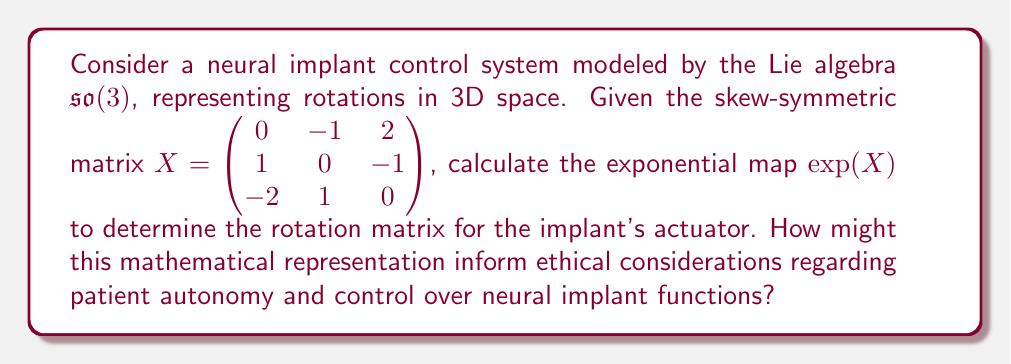What is the answer to this math problem? To calculate the exponential map for the given skew-symmetric matrix $X$, we'll follow these steps:

1) First, we need to find the eigenvalues of $X$. The characteristic polynomial is:
   $$\det(X - \lambda I) = -\lambda^3 - 6\lambda = -\lambda(\lambda^2 + 6) = 0$$
   The eigenvalues are $\lambda_1 = 0$, $\lambda_2 = i\sqrt{6}$, and $\lambda_3 = -i\sqrt{6}$.

2) The rotation angle $\theta$ can be calculated from the norm of $X$:
   $$\theta = \|X\| = \sqrt{(-1)^2 + 2^2 + 1^2 + (-1)^2 + (-2)^2 + 1^2} = \sqrt{14}$$

3) Now we can use Rodrigues' formula to calculate $\exp(X)$:
   $$\exp(X) = I + \frac{\sin\theta}{\theta}X + \frac{1-\cos\theta}{\theta^2}X^2$$

4) Let's calculate $X^2$:
   $$X^2 = \begin{pmatrix} -5 & -1 & -2 \\ -1 & -5 & -2 \\ 2 & 2 & -4 \end{pmatrix}$$

5) Now we can substitute these values into Rodrigues' formula:
   $$\exp(X) = I + \frac{\sin\sqrt{14}}{\sqrt{14}}X + \frac{1-\cos\sqrt{14}}{14}X^2$$

6) Evaluating this expression gives us the rotation matrix:
   $$\exp(X) \approx \begin{pmatrix} 
   0.4067 & -0.6790 & 0.6109 \\
   0.6790 & 0.7017 & 0.2161 \\
   -0.6109 & 0.2161 & 0.7616
   \end{pmatrix}$$

This rotation matrix represents the transformation applied by the neural implant's actuator. From an ethical perspective, this mathematical representation raises important considerations:

1) Patient autonomy: The precise control over neural functions implied by this matrix may impact a patient's sense of self-control and autonomy.
2) Informed consent: The complexity of these calculations highlights the challenge of ensuring patients fully understand the implant's capabilities.
3) Safety and reversibility: The ability to apply specific rotations to neural signals raises questions about the long-term effects and reversibility of the implant's actions.
4) Privacy and data protection: The mathematical precision of the control system implies detailed data collection, raising concerns about patient privacy.
5) Enhancement vs. treatment: The fine-grained control represented by this matrix blurs the line between medical treatment and human enhancement, a key bioethical debate.
Answer: The exponential map $\exp(X)$ for the given skew-symmetric matrix $X$ is approximately:

$$\exp(X) \approx \begin{pmatrix} 
0.4067 & -0.6790 & 0.6109 \\
0.6790 & 0.7017 & 0.2161 \\
-0.6109 & 0.2161 & 0.7616
\end{pmatrix}$$

This rotation matrix represents the transformation applied by the neural implant's actuator, raising ethical considerations regarding patient autonomy, informed consent, safety, privacy, and the boundary between medical treatment and human enhancement. 